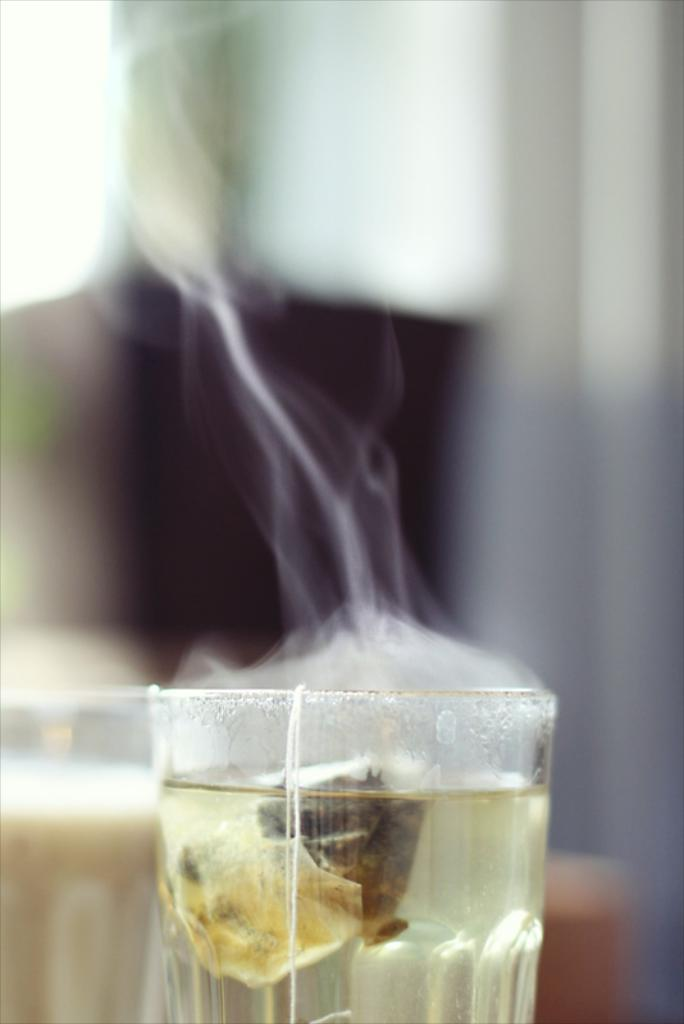What color is the cup in the image? The cup in the image is green. What is on top of the green cup? There is a tea bag on the green cup. What other container for hot beverages is visible in the image? There is a tea glass in the image. Can you describe the background of the image? The background of the image is blurry. How many zebras can be seen crossing the river in the image? There are no zebras or rivers present in the image. 